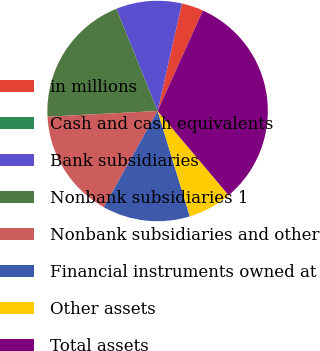<chart> <loc_0><loc_0><loc_500><loc_500><pie_chart><fcel>in millions<fcel>Cash and cash equivalents<fcel>Bank subsidiaries<fcel>Nonbank subsidiaries 1<fcel>Nonbank subsidiaries and other<fcel>Financial instruments owned at<fcel>Other assets<fcel>Total assets<nl><fcel>3.21%<fcel>0.0%<fcel>9.63%<fcel>19.72%<fcel>16.05%<fcel>12.84%<fcel>6.42%<fcel>32.1%<nl></chart> 